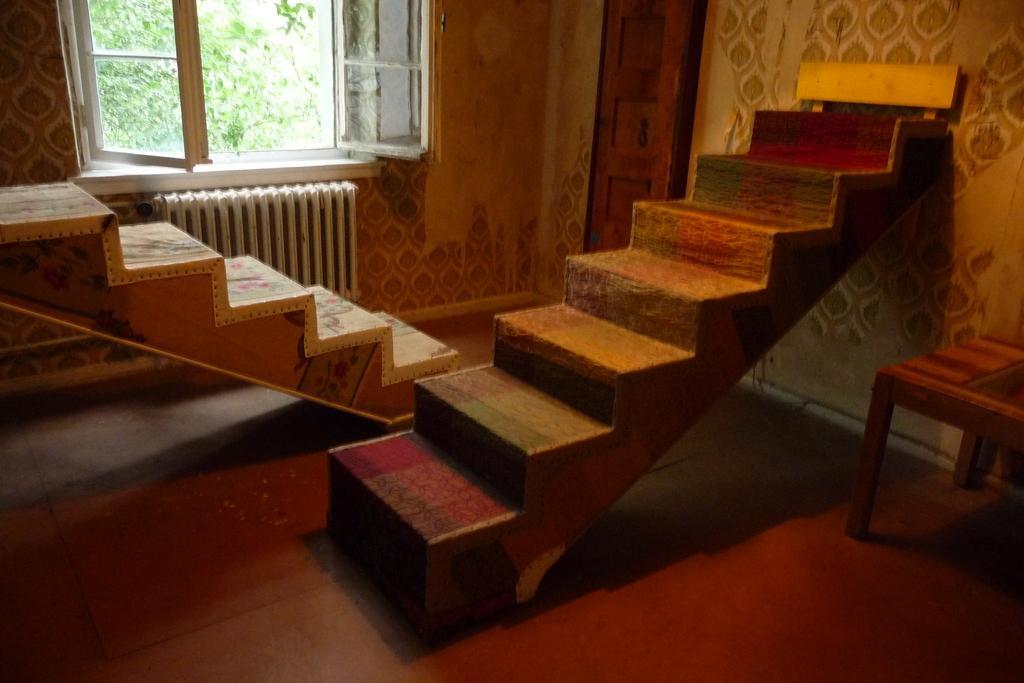Describe this image in one or two sentences. In this image we can see stairs. Behind the stairs we can see a window, wall, door and a tree. On the right side, we can see a wall and a table. 